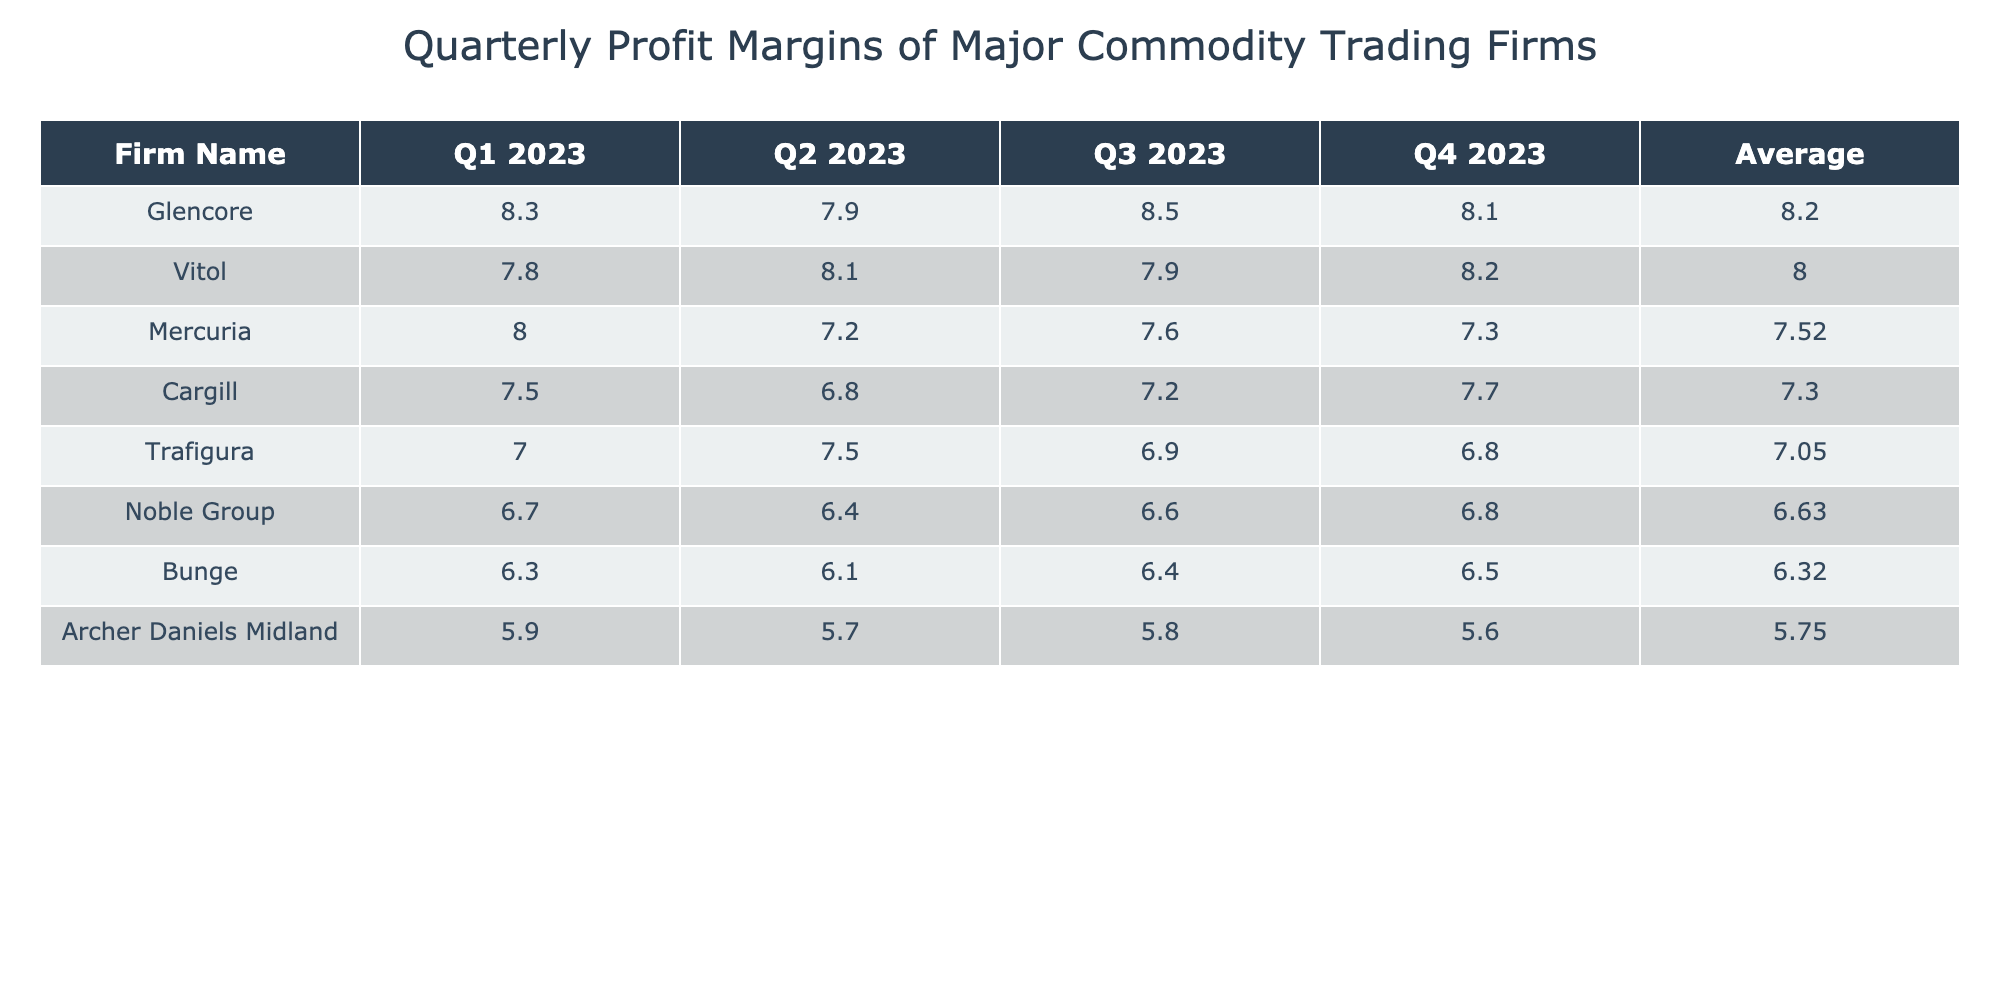What is the highest profit margin achieved by Glencore? According to the table, Glencore's profit margins across the four quarters are 8.3%, 7.9%, 8.5%, and 8.1%. The highest value among these is 8.5%.
Answer: 8.5% Which firm had the lowest profit margin in Q2 2023? In Q2 2023, the profit margins for each firm are as follows: Glencore 7.9%, Cargill 6.8%, Noble Group 6.4%, Archer Daniels Midland 5.7%, Bunge 6.1%, Trafigura 7.5%, Mercuria 7.2%, and Vitol 8.1%. The lowest value is 5.7% from Archer Daniels Midland.
Answer: 5.7% What is the average profit margin for Cargill across all four quarters? The profit margins for Cargill across the quarters are 7.5%, 6.8%, 7.2%, and 7.7%. To find the average, we sum these values: 7.5 + 6.8 + 7.2 + 7.7 = 29.2. There are 4 quarters, so the average profit margin is 29.2 / 4 = 7.3%.
Answer: 7.3% Did Mercuria have a consistent profit margin over the four quarters? Mercuria's profit margins are: Q1 8.0%, Q2 7.2%, Q3 7.6%, and Q4 7.3%. To assess consistency, we can check the range of the values: from 7.2% to 8.0%, meaning it fluctuated rather than being stable. Therefore, Mercuria did not have a consistent profit margin over the quarters.
Answer: No Which firm had the highest average profit margin overall? To find the firm with the highest average, we need to calculate the average for each firm based on their quarterly profit margins. After all calculations, we find the averages for each firm. Glencore has an average profit margin of 8.2%, which is the highest compared to others.
Answer: Glencore 